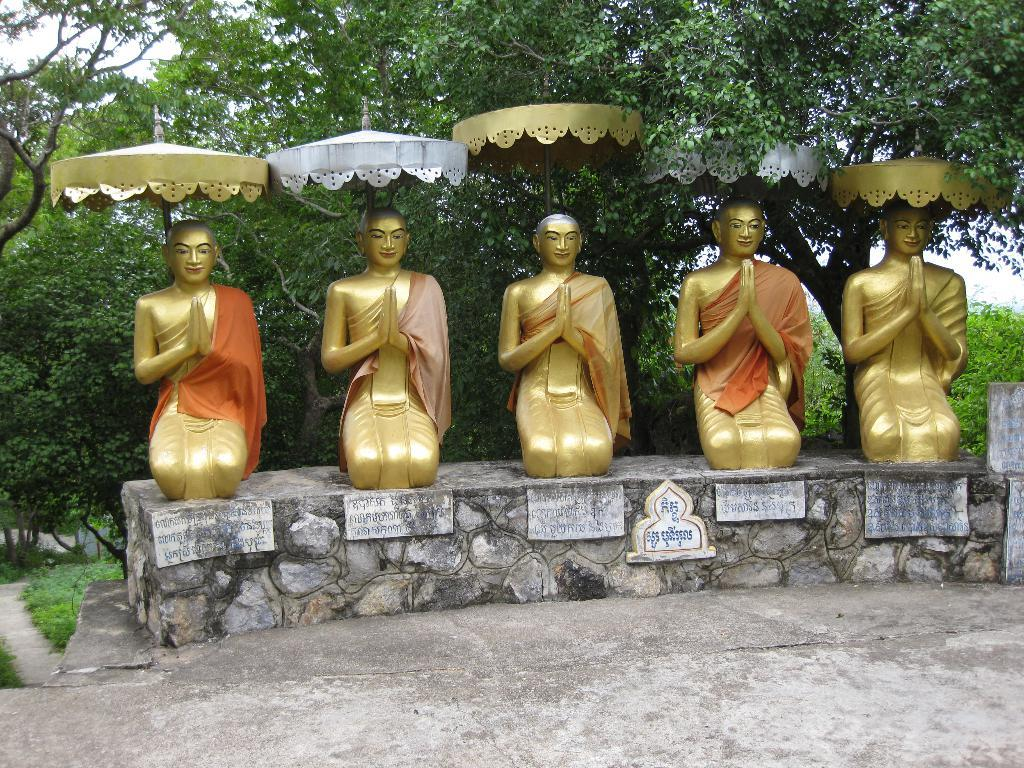What type of objects can be seen in the image? There are statues in the image. What can be seen in the distance behind the statues? There are trees in the background of the image. What type of temporary shelters are present in the image? There are tents in the image. What type of structure can be seen in the image? There is a wall in the image. What type of market can be seen in the image? There is no market present in the image; it features statues, trees, tents, and a wall. What type of hands are depicted on the statues in the image? The statues in the image do not have hands, as they are not human figures. 